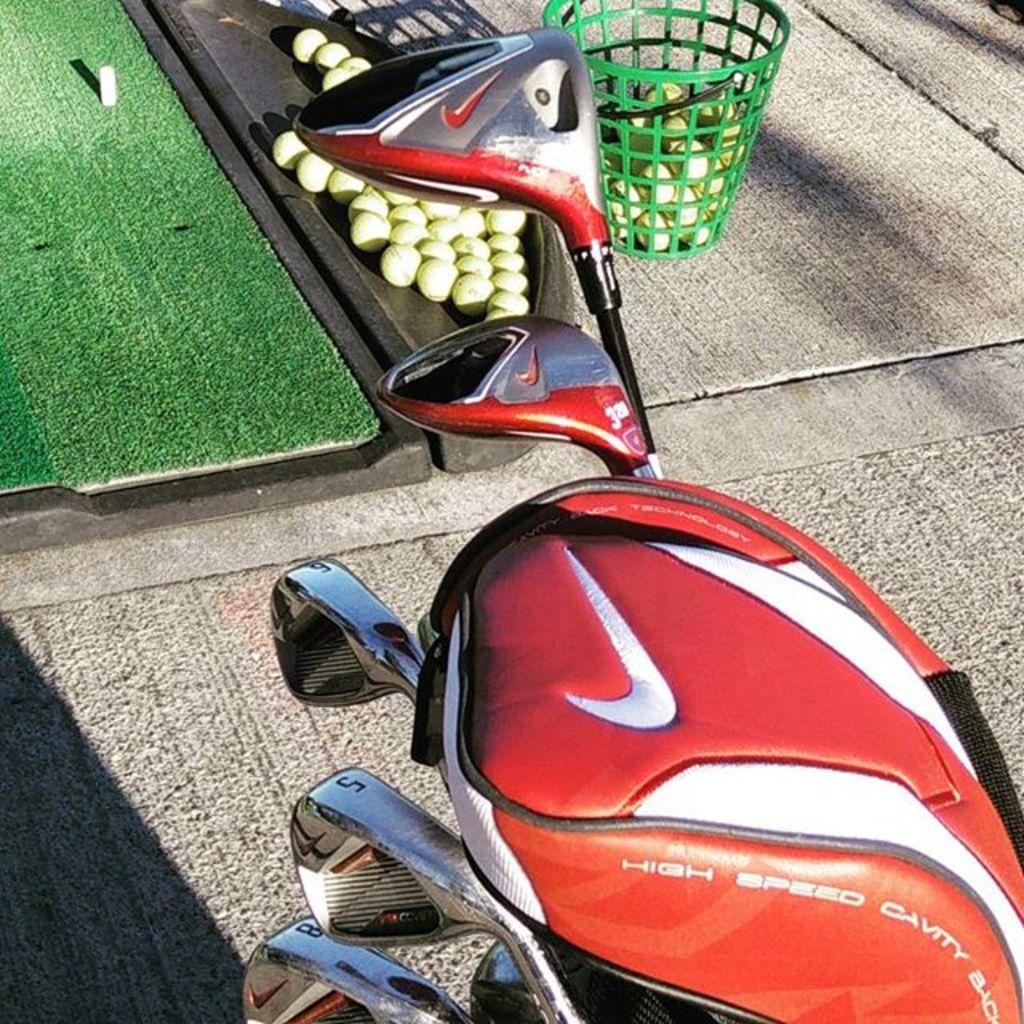Describe this image in one or two sentences. In the foreground of this image, we see a red colored bag with five golf balls in it. In the background, on surface we see a green basket with balls. On left top corner, there is a green mat. 